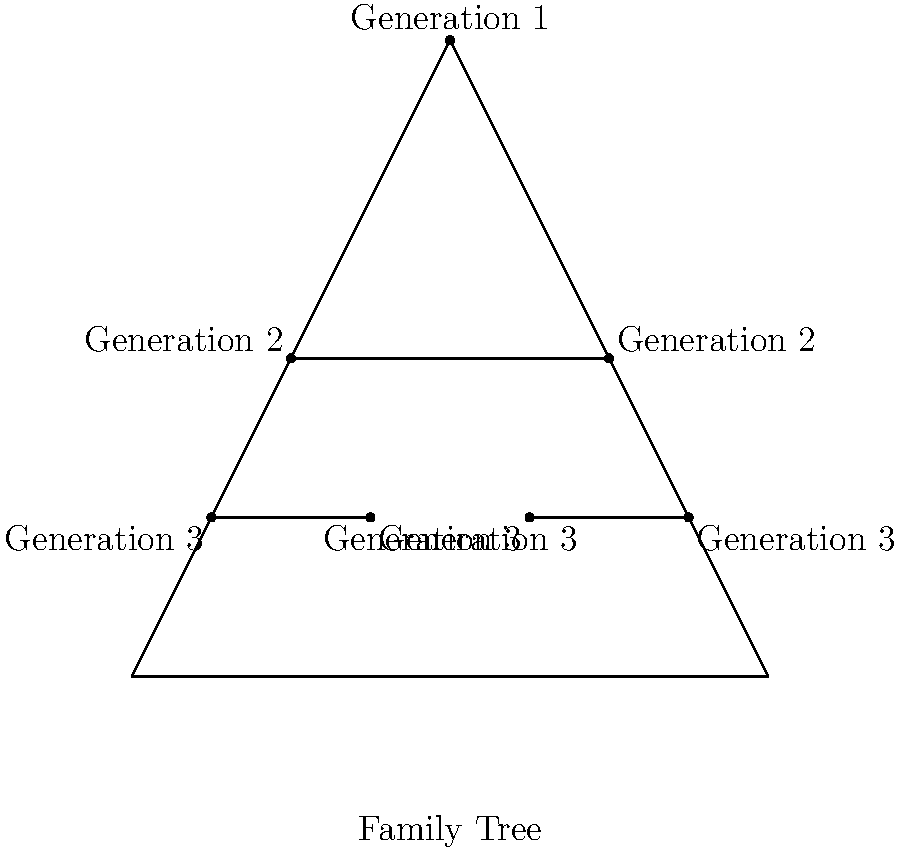In the context of representing a multi-generational saga's narrative structure, how does the use of a family tree diagram, as shown above, contribute to the understanding of character relationships and storylines? Discuss the advantages and potential limitations of this approach in storytelling. To answer this question, let's break down the advantages and limitations of using a family tree diagram to represent a multi-generational saga's narrative structure:

1. Advantages:
   a) Visual clarity: The family tree provides a clear, hierarchical representation of characters across generations.
   b) Relationships at a glance: Readers can quickly identify familial connections between characters.
   c) Temporal structure: The generations are clearly delineated, giving a sense of the saga's timeline.
   d) Character context: Each character's position in the family provides immediate context for their role in the story.
   e) Narrative foreshadowing: The structure can hint at potential conflicts or alliances based on family ties.

2. Limitations:
   a) Oversimplification: Complex relationships or non-traditional family structures may not be easily represented.
   b) Lack of character depth: The diagram doesn't convey personality traits, motivations, or character development.
   c) Static representation: The family tree doesn't show how relationships evolve over time.
   d) Exclusion of non-familial relationships: Important friendships or rivalries outside the family aren't represented.
   e) Limited narrative scope: The diagram focuses solely on genealogy, potentially overlooking other crucial narrative elements.

3. Storytelling implications:
   a) The family tree can serve as a reference point for readers to navigate complex character networks.
   b) It can be used to reveal surprising connections or hidden lineages as plot twists.
   c) The structure might inspire authors to explore themes of inheritance, legacy, and generational patterns.
   d) It could be complemented with additional information (e.g., character descriptions, key events) to provide a more comprehensive narrative overview.

In conclusion, while a family tree diagram offers a valuable visual aid for understanding character relationships and generational structures in a multi-generational saga, it should be considered as one tool among many in crafting and analyzing complex narratives.
Answer: Family tree diagrams provide clear visual representation of character relationships and generational structures but may oversimplify complex narratives and exclude non-familial elements. 